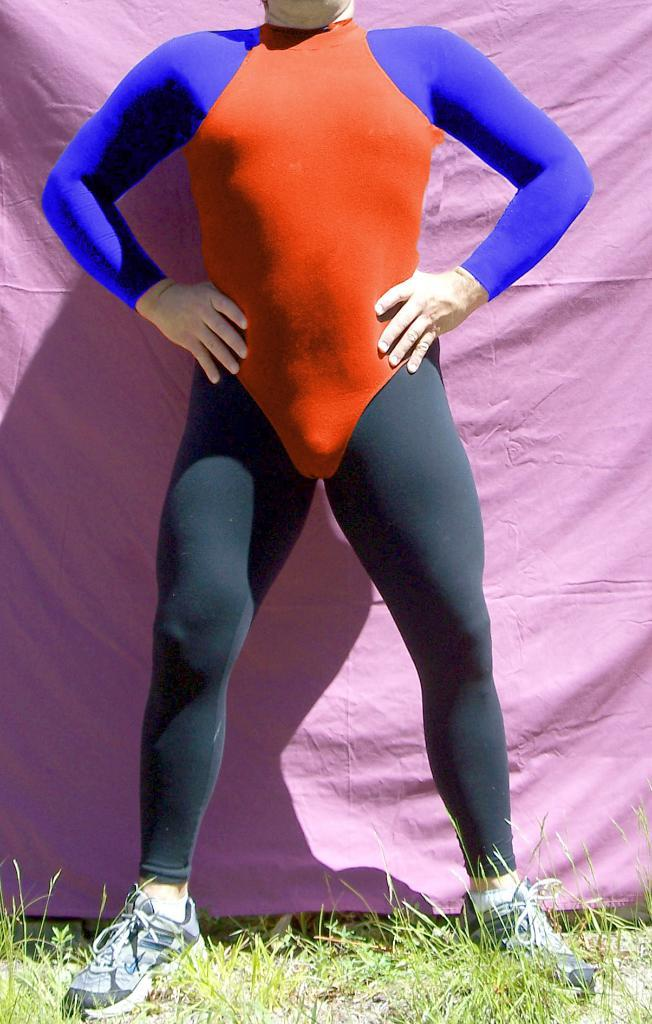Who is present in the image? There is a man in the image. What colors are present in the man's outfit? The man is wearing an outfit with orange, blue, and black colors. What is the man standing on? The man is standing on the ground. What color is the background of the image? The background of the image is pink. What type of vegetation is present on the ground? There is grass on the ground. What type of loss is the man experiencing in the image? There is no indication of loss in the image; the man is simply standing on the ground with a specific outfit and in a pink background. 